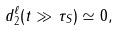<formula> <loc_0><loc_0><loc_500><loc_500>d _ { 2 } ^ { \ell } ( t \gg \tau _ { S } ) \simeq 0 ,</formula> 